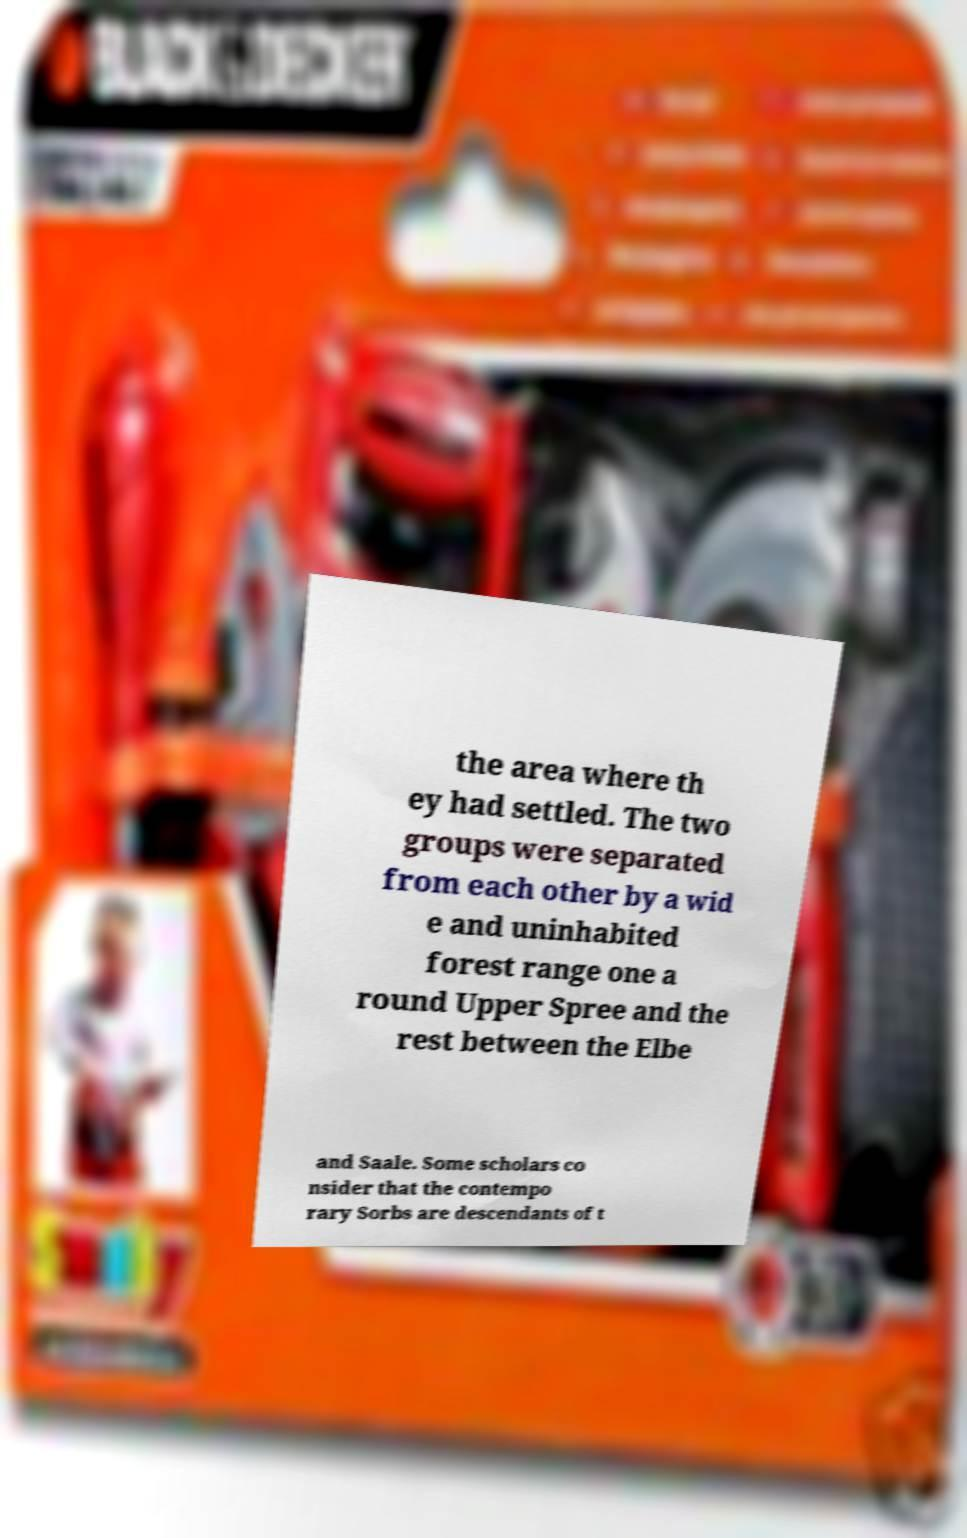There's text embedded in this image that I need extracted. Can you transcribe it verbatim? the area where th ey had settled. The two groups were separated from each other by a wid e and uninhabited forest range one a round Upper Spree and the rest between the Elbe and Saale. Some scholars co nsider that the contempo rary Sorbs are descendants of t 